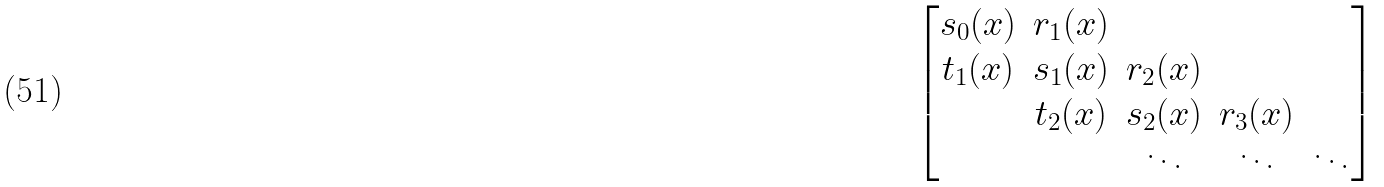<formula> <loc_0><loc_0><loc_500><loc_500>\begin{bmatrix} s _ { 0 } ( { x } ) & r _ { 1 } ( { x } ) & & & \\ t _ { 1 } ( { x } ) & s _ { 1 } ( { x } ) & r _ { 2 } ( { x } ) & & \\ & t _ { 2 } ( { x } ) & s _ { 2 } ( { x } ) & r _ { 3 } ( { x } ) & \\ & & \ddots & \ddots & \ddots \\ \end{bmatrix}</formula> 